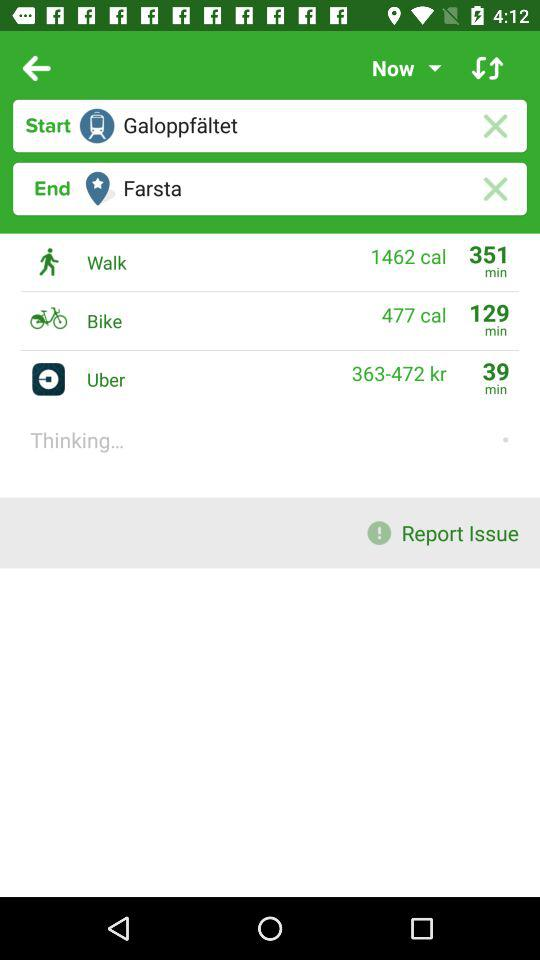How much time will it take by bike? It will take 129 minutes by bike. 